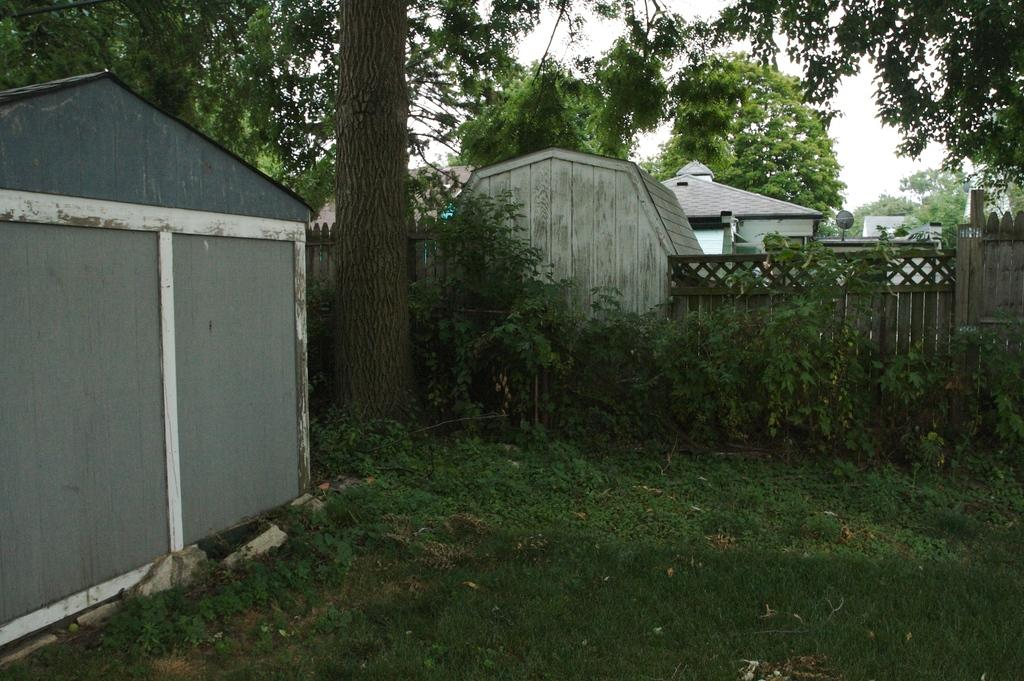What type of structures can be seen in the image? There are buildings and a shed in the image. What material is used for the walls of the shed? The walls of the shed are made of wood. What type of vegetation is present in the image? There are plants and trees in the image. What is attached to the top of the shed? There is an antenna on the shed in the image. What can be seen in the sky in the image? The sky is visible in the image. What type of root can be seen growing from the antenna in the image? There is no root growing from the antenna in the image; it is an antenna attached to the shed. What type of pickle is being used as a decoration on the plants in the image? There are no pickles present in the image; it features plants and trees without any pickles. 